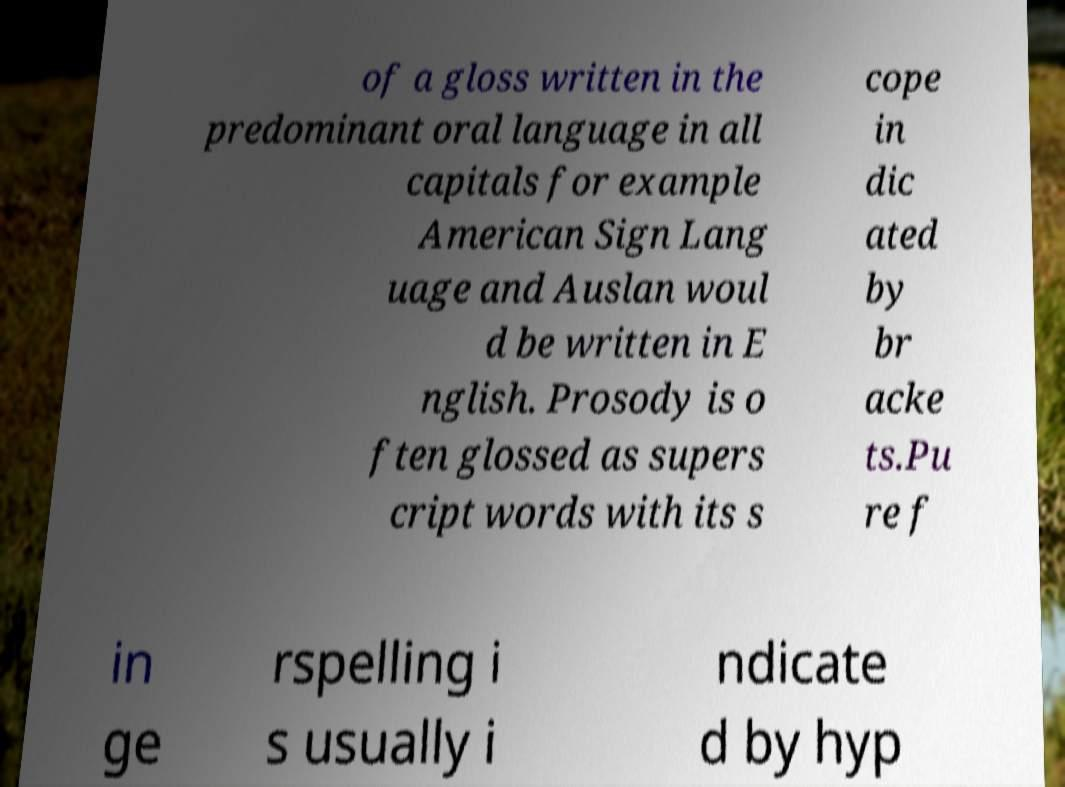For documentation purposes, I need the text within this image transcribed. Could you provide that? of a gloss written in the predominant oral language in all capitals for example American Sign Lang uage and Auslan woul d be written in E nglish. Prosody is o ften glossed as supers cript words with its s cope in dic ated by br acke ts.Pu re f in ge rspelling i s usually i ndicate d by hyp 